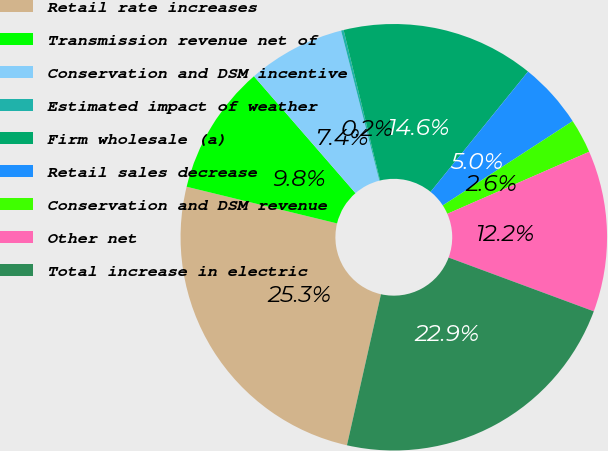<chart> <loc_0><loc_0><loc_500><loc_500><pie_chart><fcel>Retail rate increases<fcel>Transmission revenue net of<fcel>Conservation and DSM incentive<fcel>Estimated impact of weather<fcel>Firm wholesale (a)<fcel>Retail sales decrease<fcel>Conservation and DSM revenue<fcel>Other net<fcel>Total increase in electric<nl><fcel>25.28%<fcel>9.81%<fcel>7.41%<fcel>0.19%<fcel>14.62%<fcel>5.0%<fcel>2.6%<fcel>12.21%<fcel>22.88%<nl></chart> 